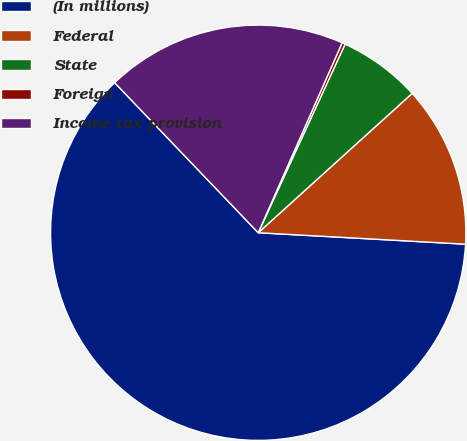Convert chart. <chart><loc_0><loc_0><loc_500><loc_500><pie_chart><fcel>(In millions)<fcel>Federal<fcel>State<fcel>Foreign<fcel>Income tax provision<nl><fcel>61.98%<fcel>12.59%<fcel>6.42%<fcel>0.25%<fcel>18.77%<nl></chart> 